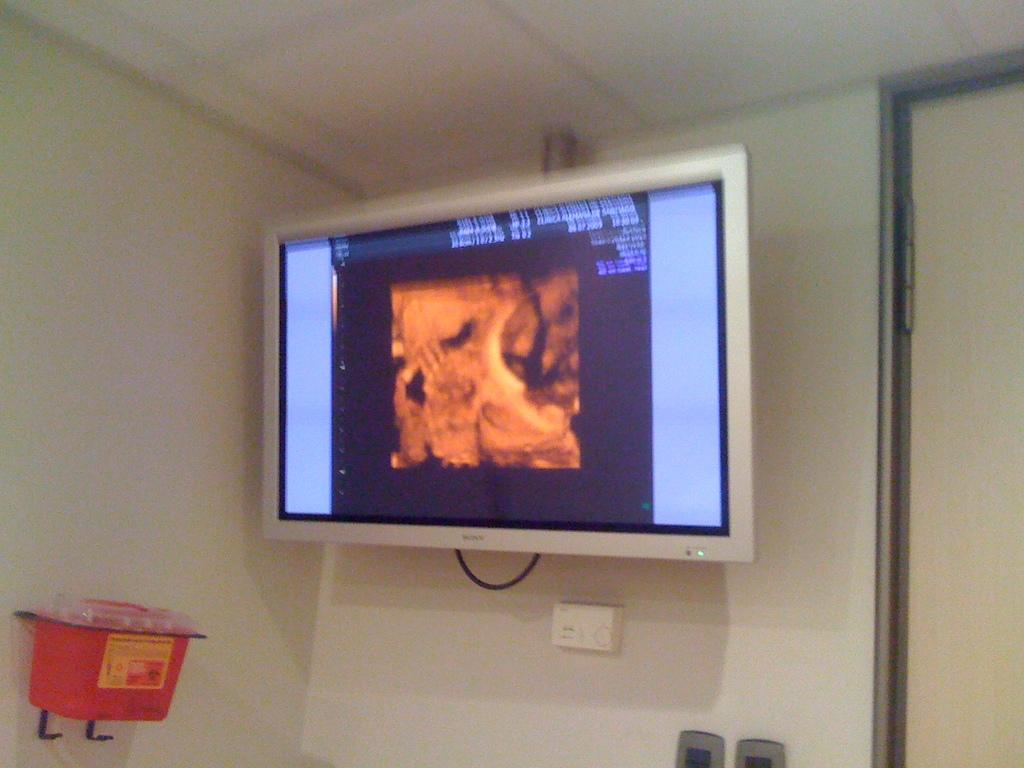What is the main object in the center of the image? There is a TV in the center of the image. What can be seen on the left side of the image? There is a red color object on the wall on the left side of the image. What is located on the right side of the image? There is a door on the right side of the image. How does the wind affect the TV in the image? There is no wind present in the image, and therefore it does not affect the TV. What type of marble is visible on the floor in the image? There is no marble visible in the image; it only features a TV, a red object on the wall, and a door. 